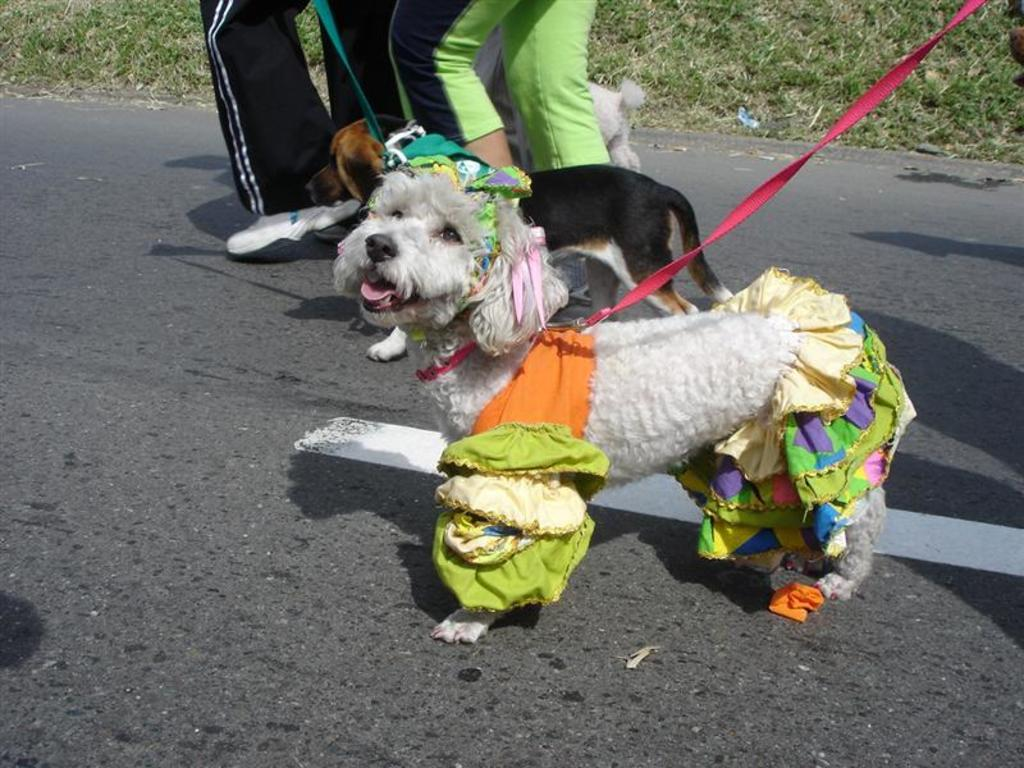What type of animals are in the image? There are dogs in the image. How are the dogs being controlled or guided in the image? The dogs have leashes in the image. What are the people in the image doing? The people are walking along the road in the image. What type of vegetation can be seen in the background of the image? The background of the image includes grass. What type of request can be seen written on the spade in the image? There is no spade present in the image, and therefore no such request can be observed. 